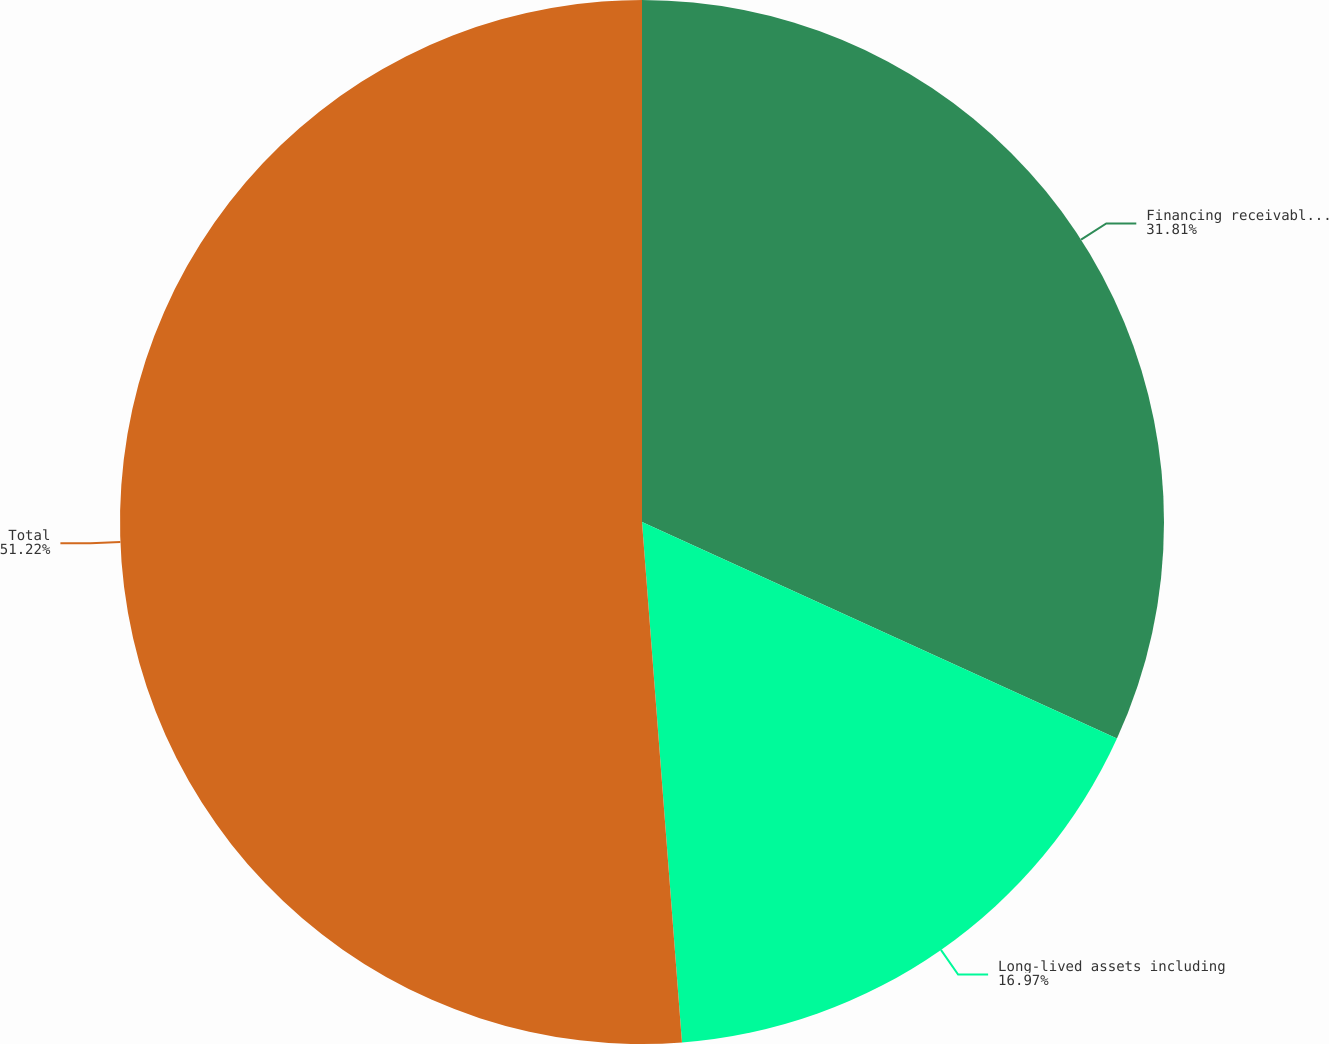Convert chart. <chart><loc_0><loc_0><loc_500><loc_500><pie_chart><fcel>Financing receivables and<fcel>Long-lived assets including<fcel>Total<nl><fcel>31.81%<fcel>16.97%<fcel>51.22%<nl></chart> 